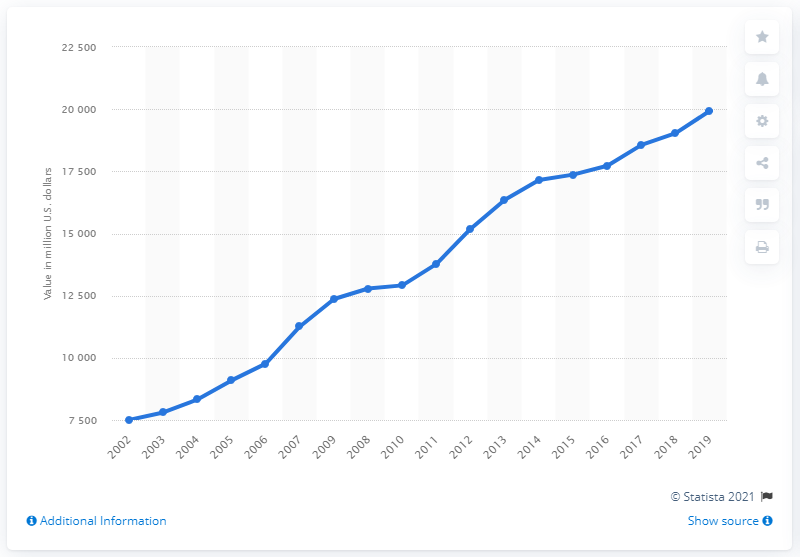Point out several critical features in this image. In 2019, the value of U.S. wholesale inventories of beer, wine, and distilled alcoholic beverages was approximately 19,937. 